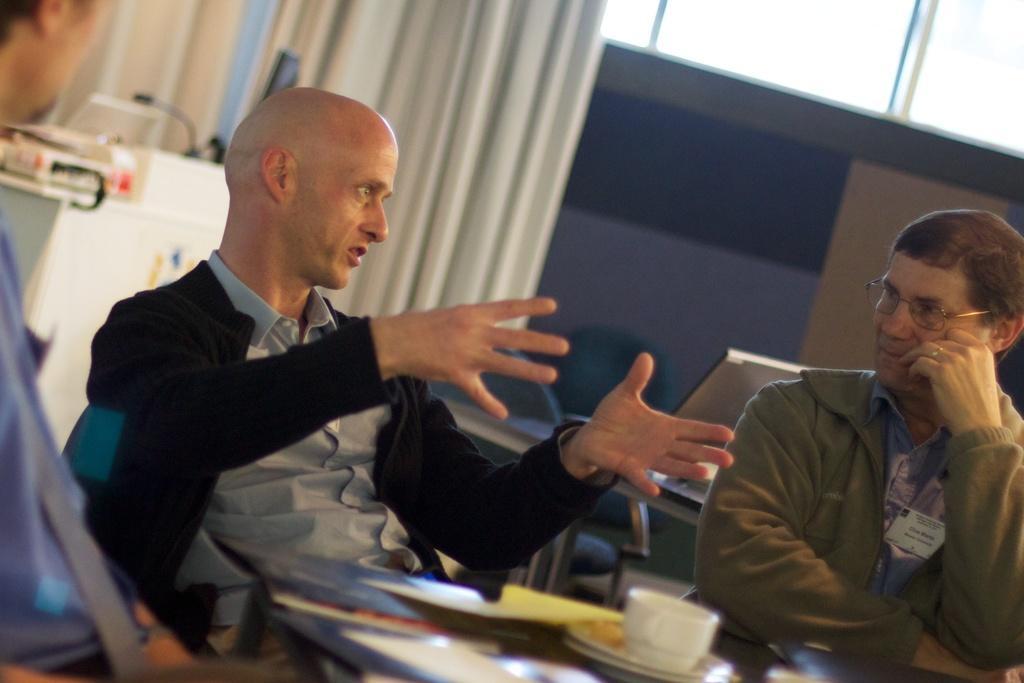How would you summarize this image in a sentence or two? In this picture there is a man who is wearing black jacket and grey shirt. besides him there is another man who is wearing green sweater, blue shirt and spectacle. Both of them are sitting near to the table. On the table we can see files, papers, saucer and cups. On the left there is another man who is sitting on the chair. In the background we can see the chair, table, cloth and wall. On the top right we can see the sky through the window. 